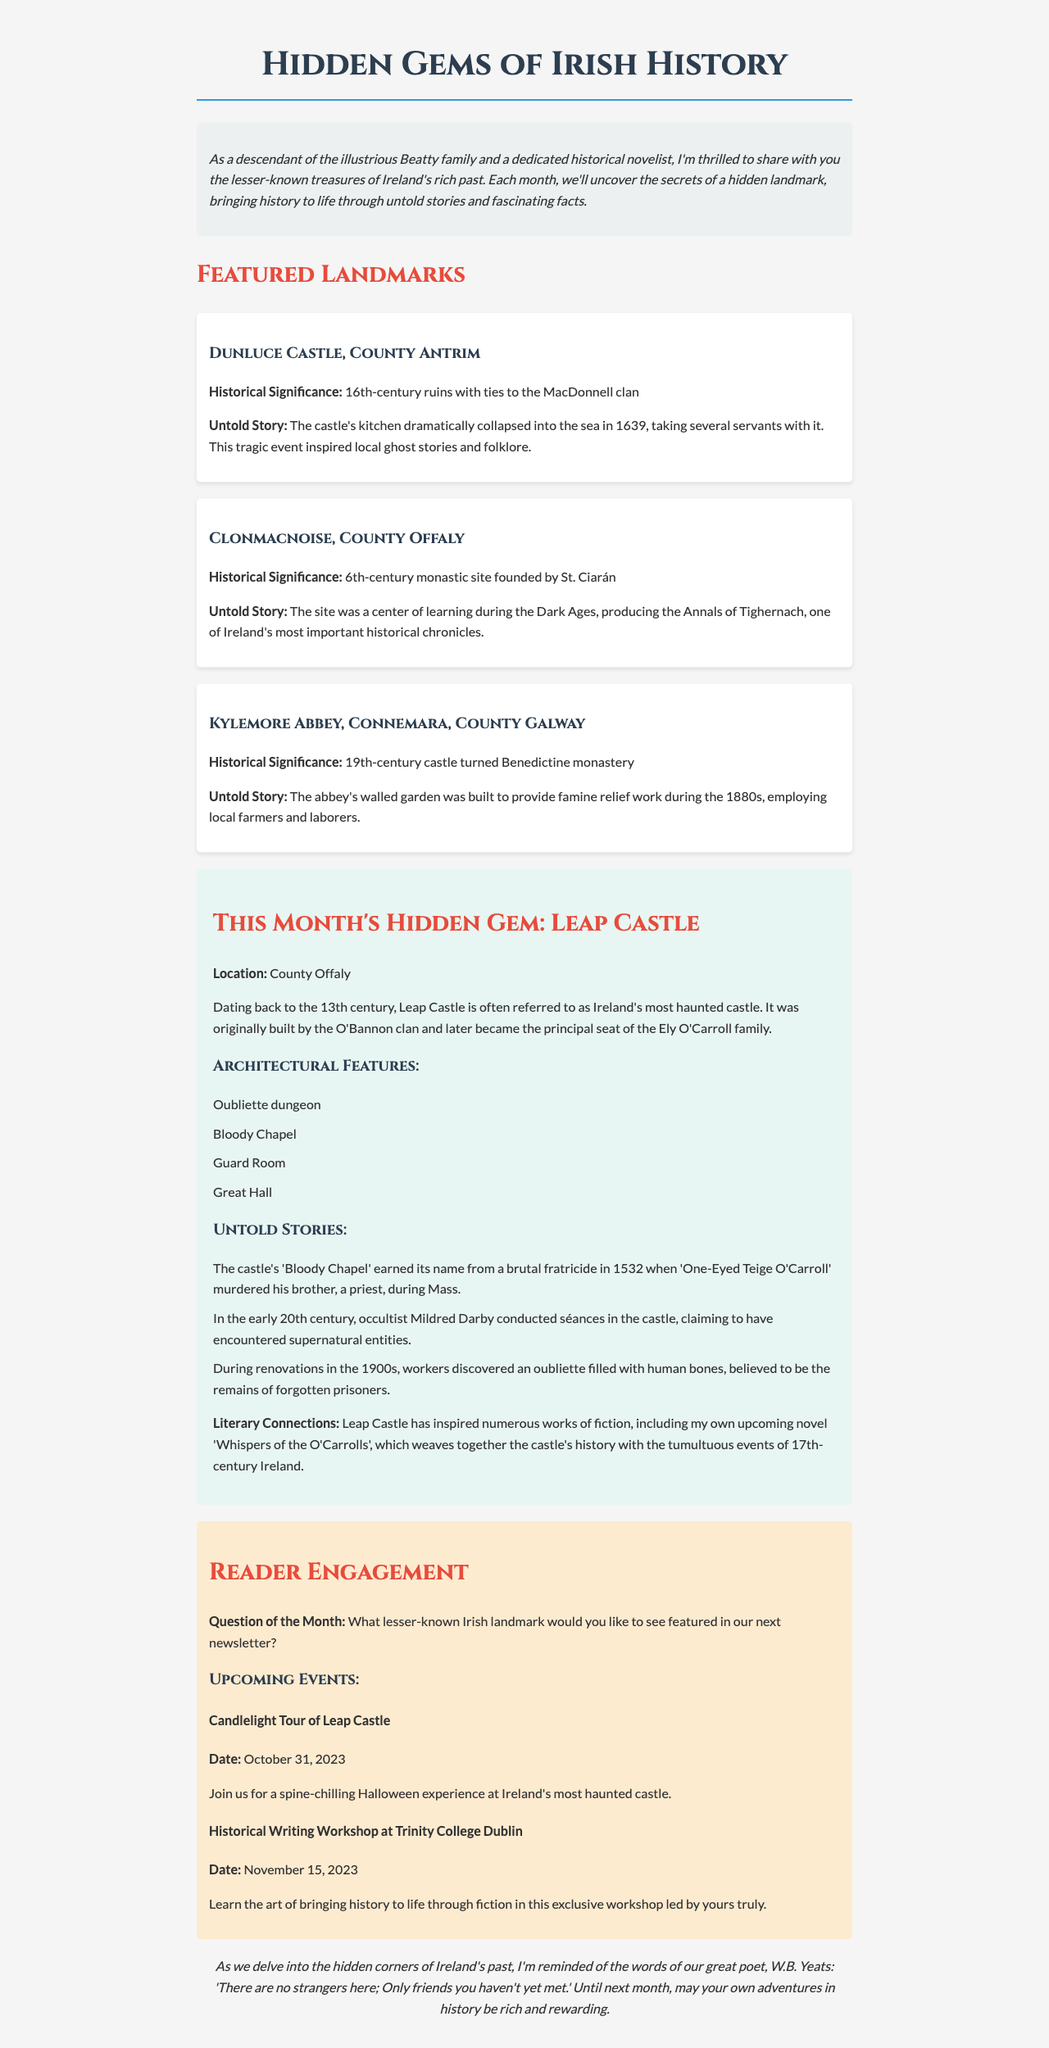What is the title of the newsletter? The title of the newsletter is clearly stated at the beginning of the document.
Answer: Hidden Gems of Irish History Where is Leap Castle located? The document specifies the location of Leap Castle in the spotlight section.
Answer: County Offaly What century does Dunluce Castle date back to? The historical significance of Dunluce Castle includes its date, mentioned in the featured landmarks section.
Answer: 16th century What tragic event occurred at Dunluce Castle in 1639? The untold story of Dunluce Castle describes a specific event that took place, providing insight into its historical narrative.
Answer: The kitchen collapsed into the sea Who founded Clonmacnoise? The document notes the founder of Clonmacnoise in the historical significance section of featured landmarks.
Answer: St. Ciarán How many architectural features are listed for Leap Castle? The architectural features section lists items related to Leap Castle, indicating a specific count.
Answer: Four What is the upcoming event on October 31, 2023? The upcoming events section provides specific dates and details about future events, including this particular date.
Answer: Candlelight Tour of Leap Castle What type of literature has Leap Castle inspired? The spotlight section discusses the literary connections of Leap Castle, indicating the category of inspiration.
Answer: Works of fiction What is the question of the month in the reader engagement section? The document includes a specific question aimed at engaging readers, found in the reader engagement section.
Answer: What lesser-known Irish landmark would you like to see featured in our next newsletter? 